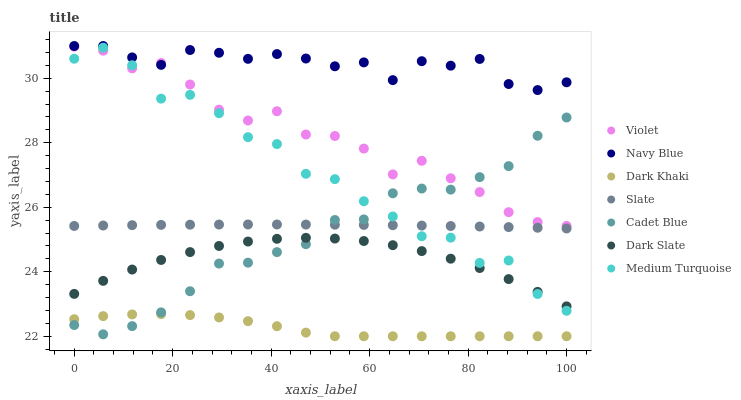Does Dark Khaki have the minimum area under the curve?
Answer yes or no. Yes. Does Navy Blue have the maximum area under the curve?
Answer yes or no. Yes. Does Slate have the minimum area under the curve?
Answer yes or no. No. Does Slate have the maximum area under the curve?
Answer yes or no. No. Is Slate the smoothest?
Answer yes or no. Yes. Is Medium Turquoise the roughest?
Answer yes or no. Yes. Is Navy Blue the smoothest?
Answer yes or no. No. Is Navy Blue the roughest?
Answer yes or no. No. Does Dark Khaki have the lowest value?
Answer yes or no. Yes. Does Slate have the lowest value?
Answer yes or no. No. Does Navy Blue have the highest value?
Answer yes or no. Yes. Does Slate have the highest value?
Answer yes or no. No. Is Dark Khaki less than Violet?
Answer yes or no. Yes. Is Navy Blue greater than Slate?
Answer yes or no. Yes. Does Dark Slate intersect Medium Turquoise?
Answer yes or no. Yes. Is Dark Slate less than Medium Turquoise?
Answer yes or no. No. Is Dark Slate greater than Medium Turquoise?
Answer yes or no. No. Does Dark Khaki intersect Violet?
Answer yes or no. No. 